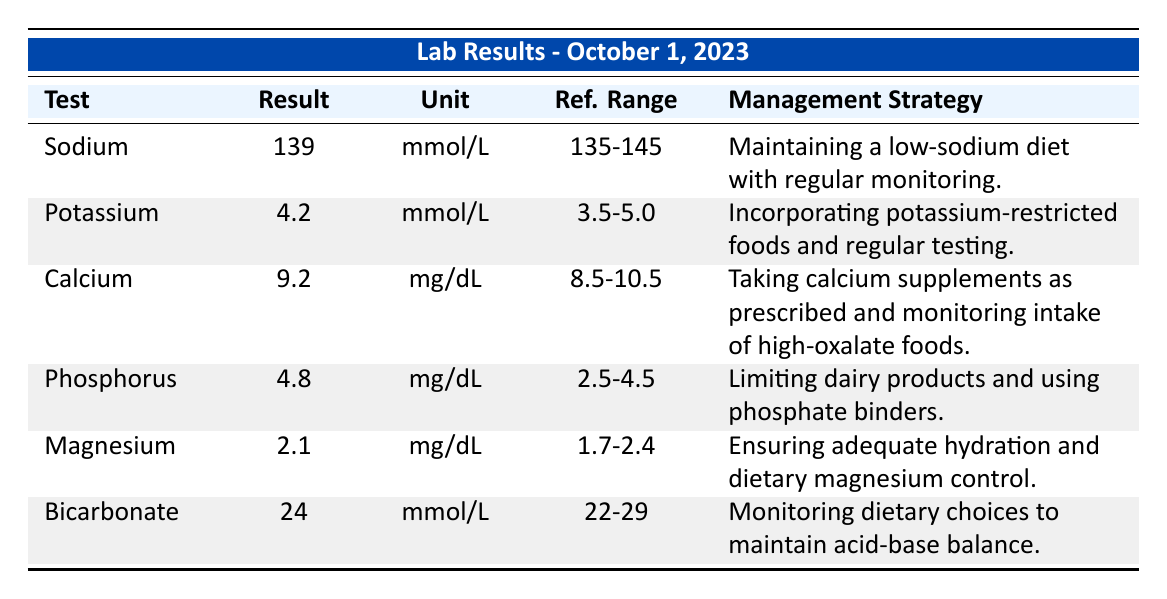What is the result for Sodium? The table states that the result for Sodium is 139.
Answer: 139 What is the management strategy for Potassium? The management strategy for Potassium, as per the table, is incorporating potassium-restricted foods and regular testing.
Answer: Incorporating potassium-restricted foods and regular testing Is the Calcium level within the reference range? The reference range for Calcium is 8.5-10.5, and the result is 9.2, which is within this range, hence the answer is yes.
Answer: Yes What is the difference between the Potassium and Phosphorus results? The Potassium result is 4.2 and the Phosphorus result is 4.8. The difference is calculated by subtracting Potassium from Phosphorus, which is 4.8 - 4.2 = 0.6.
Answer: 0.6 How many electrolyte levels are above their reference range? The only levels above their reference range are Phosphorus at 4.8 (reference range 2.5-4.5). Thus, there is one electrolyte level above the reference range.
Answer: 1 What is the average value of Calcium and Magnesium results? The Calcium result is 9.2 and Magnesium result is 2.1. To find the average: (9.2 + 2.1) / 2 = 11.3 / 2 = 5.65.
Answer: 5.65 Are all the electrolyte results within their reference ranges? Reviewing the table, Sodium, Potassium, Calcium, Magnesium, and Bicarbonate are within their reference ranges, but Phosphorus is above its range. Therefore, the answer is no.
Answer: No If the Sodium level increased by 3 units, would it still be within the reference range? If Sodium increases from 139 to 142 (i.e., 139 + 3), it falls within the reference range of 135-145. Therefore, it would still be within the range, making the answer yes.
Answer: Yes What strategies are recommended for managing Phosphorus levels? The table indicates that the strategy for managing Phosphorus levels is to limit dairy products and use phosphate binders.
Answer: Limit dairy products and use phosphate binders 